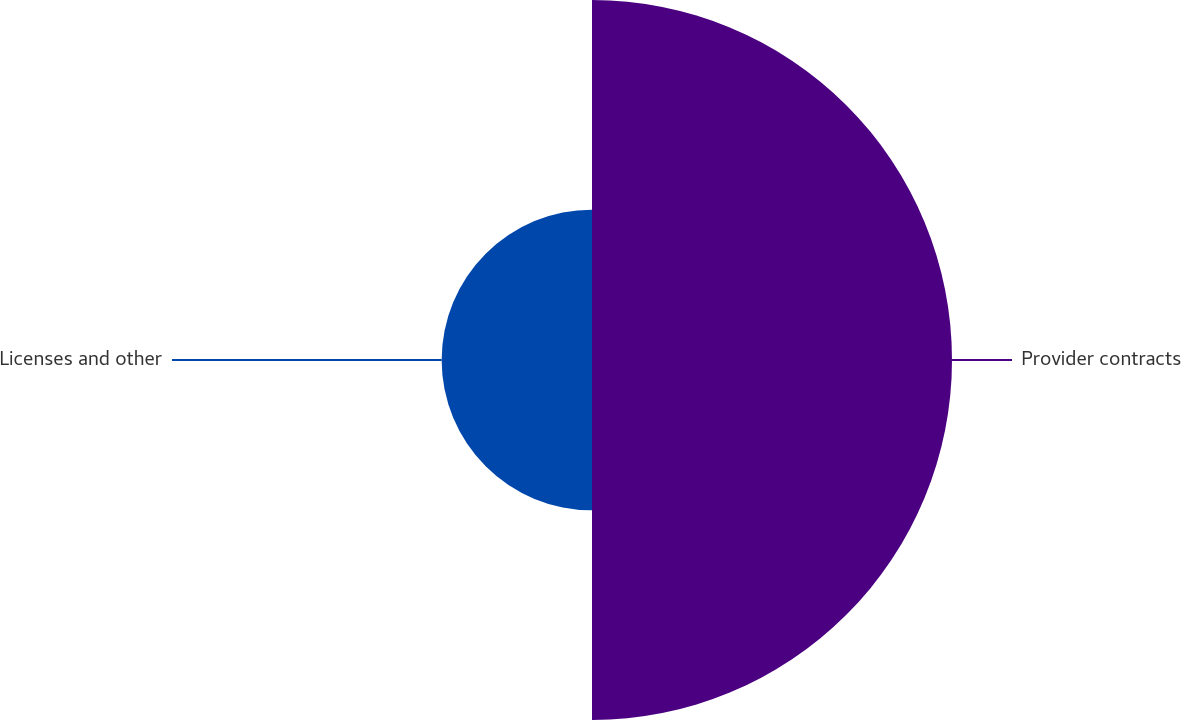<chart> <loc_0><loc_0><loc_500><loc_500><pie_chart><fcel>Provider contracts<fcel>Licenses and other<nl><fcel>70.54%<fcel>29.46%<nl></chart> 